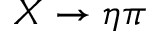Convert formula to latex. <formula><loc_0><loc_0><loc_500><loc_500>X \rightarrow \eta \pi</formula> 